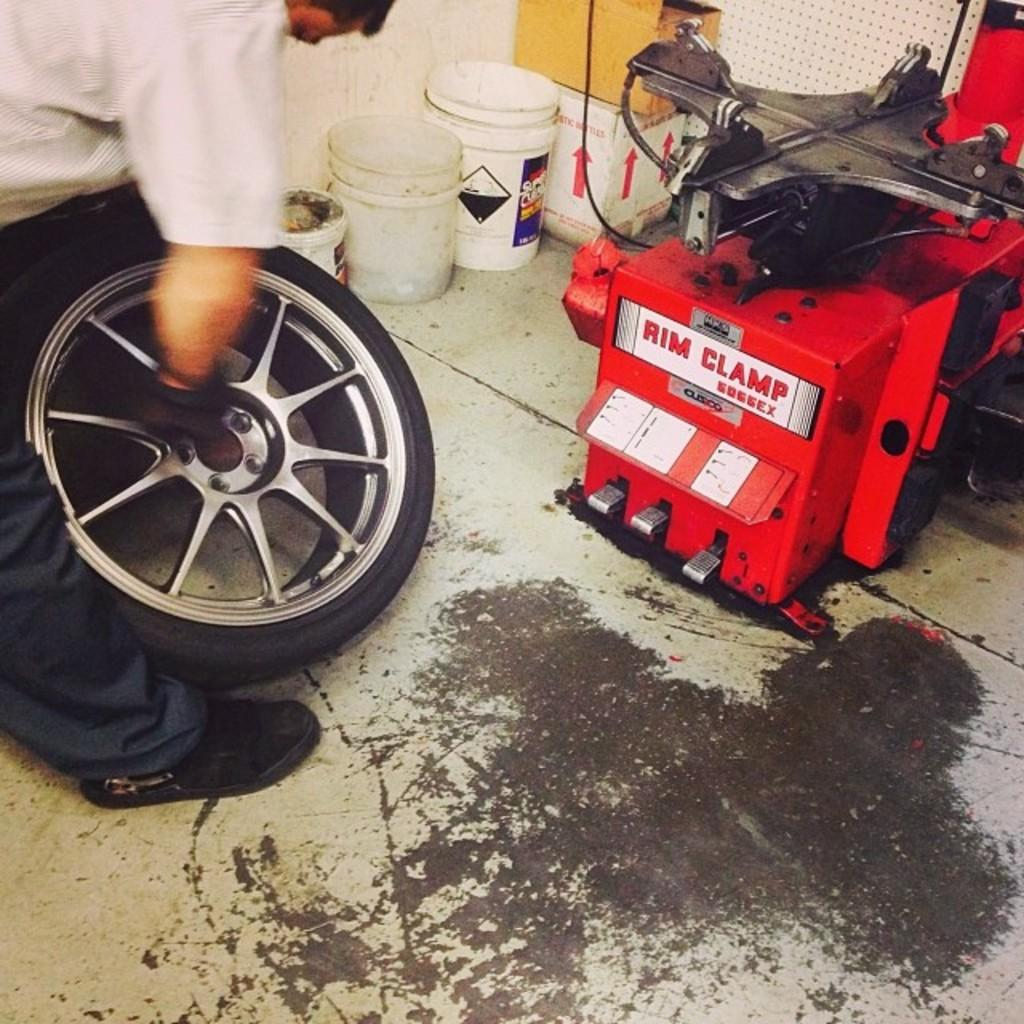Who or what is present in the image? There is a person in the image. What is the person holding? The person is holding a tire. What can be seen in the background of the image? There are buckets, a machine, and boxes in the background of the image. What is the surface visible at the bottom of the image? There is a floor visible at the bottom of the image. What type of paper is the person using to hold the tire in the image? There is no paper present in the image; the person is holding the tire with their hands. 